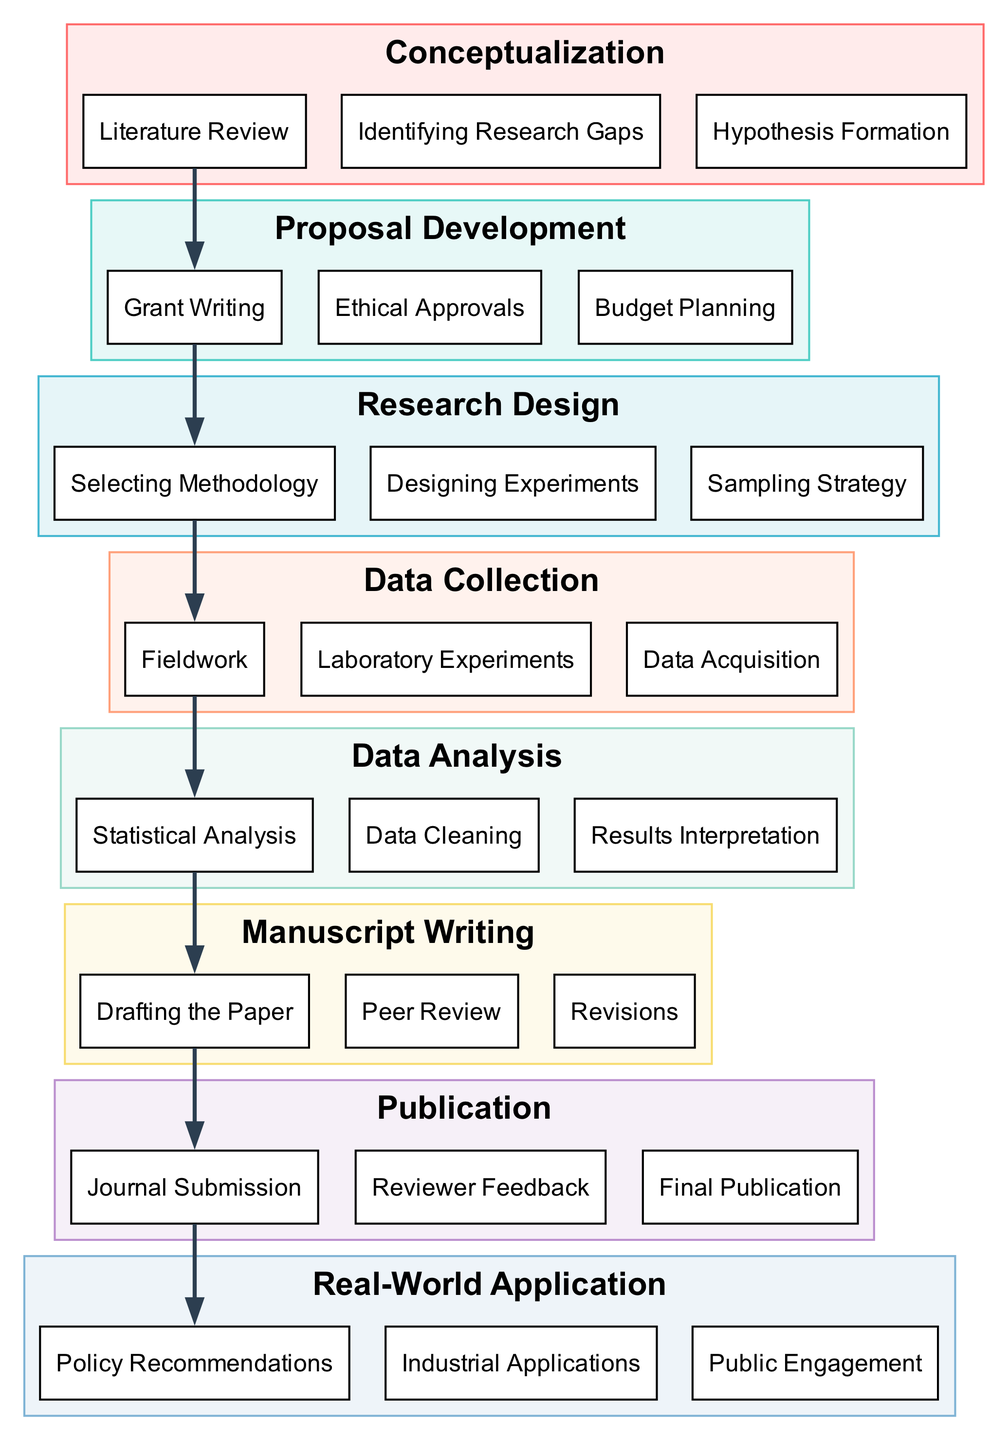What is the first block in the diagram? The first block is labeled "Conceptualization," which can be identified as it is the starting point of the lifecycle in the block diagram.
Answer: Conceptualization How many main blocks are there in total? To find the total number of blocks, we can count each block in the provided data structure. There are eight main blocks: Conceptualization, Proposal Development, Research Design, Data Collection, Data Analysis, Manuscript Writing, Publication, and Real-World Application.
Answer: Eight Which block comes after "Data Collection"? The block that directly follows "Data Collection" is "Data Analysis," established by the connection that indicates the flow from Data Collection to Data Analysis.
Answer: Data Analysis What activity is performed during the "Publication" block? Within the "Publication" block, the activities stated include Journal Submission, Reviewer Feedback, and Final Publication. These activities collectively define the core tasks in this stage.
Answer: Journal Submission Which two blocks are directly connected by a single arrow? The blocks that are directly connected by a single arrow based on the diagram structure are "Manuscript Writing" and "Publication," indicating a sequential transition from writing to publication.
Answer: Manuscript Writing and Publication What is the last block in the lifecycle? The last block in the lifecycle of the diagram is "Real-World Application," which signifies the final stage where research findings are translated into practical usage.
Answer: Real-World Application How many activities are listed under the "Research Design" block? The "Research Design" block has three activities listed within it: Selecting Methodology, Designing Experiments, and Sampling Strategy. Therefore, we can count them to get the total.
Answer: Three What connects the "Publication" block to the "Real-World Application"? The connection from the "Publication" block leads to the "Real-World Application" block, indicating that the outcomes of the publication process are utilized for practical applications in various contexts.
Answer: Real-World Application 